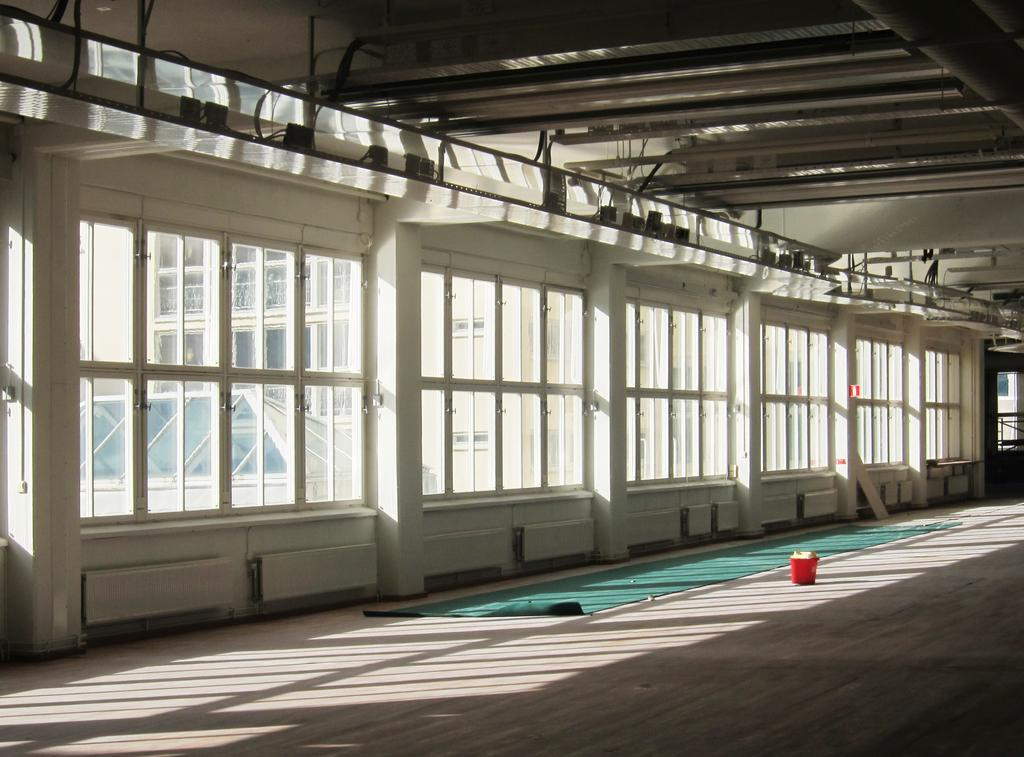What type of structure is present in the image? There is a building in the image. What feature can be observed on the building? The building has windows. What object is inside the building? There is a bucket inside the building. What is on the floor inside the building? There is a green color mat on the floor inside the building. What can be seen through the windows of the building? Another building is visible through the windows of the first building. What type of wood can be seen in the image? There is no wood present in the image. What is the source of the mist in the image? There is no mist present in the image. 